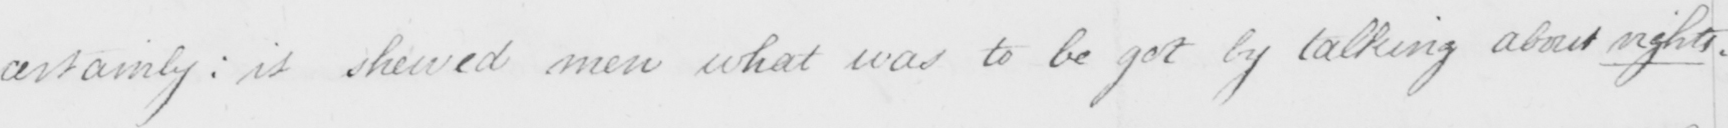Transcribe the text shown in this historical manuscript line. certainly :  it showed more what was to be got by talking about rights . 